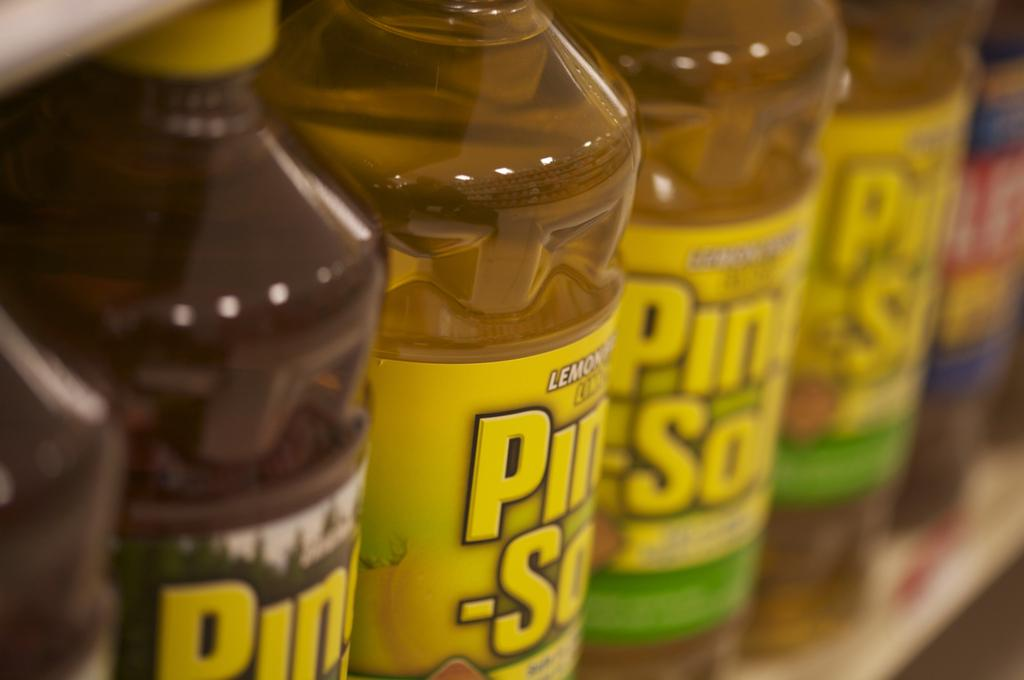Provide a one-sentence caption for the provided image. a row of pine-sol bottles next to each other on a shelf. 